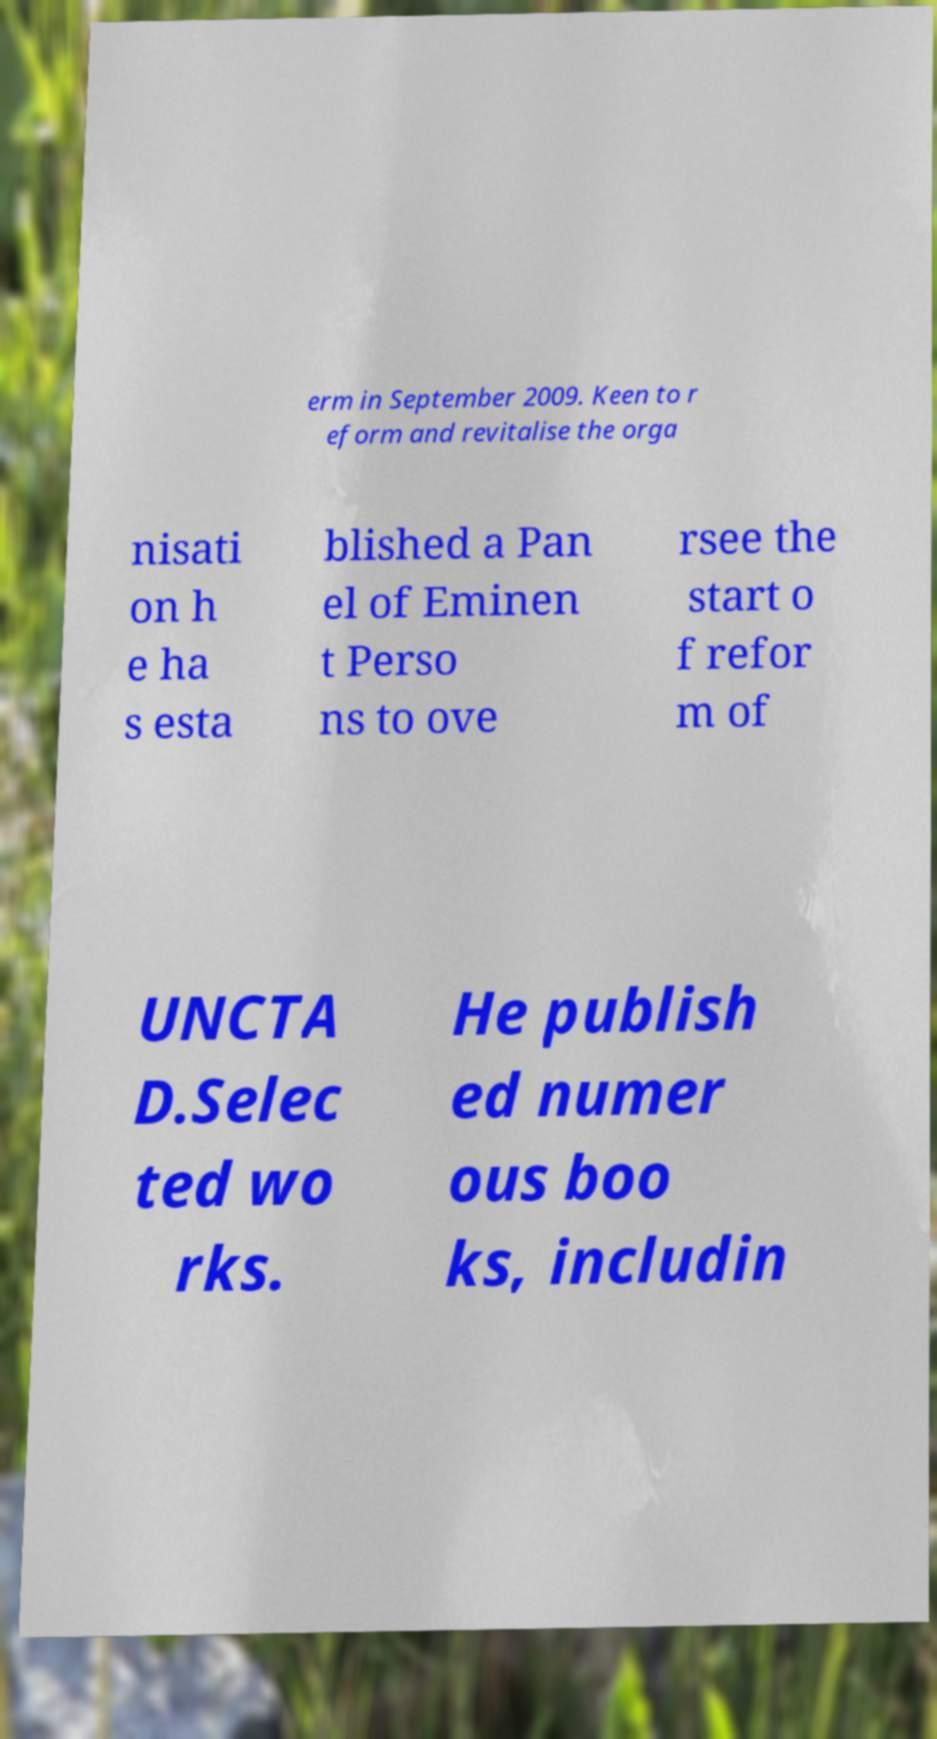Could you assist in decoding the text presented in this image and type it out clearly? erm in September 2009. Keen to r eform and revitalise the orga nisati on h e ha s esta blished a Pan el of Eminen t Perso ns to ove rsee the start o f refor m of UNCTA D.Selec ted wo rks. He publish ed numer ous boo ks, includin 